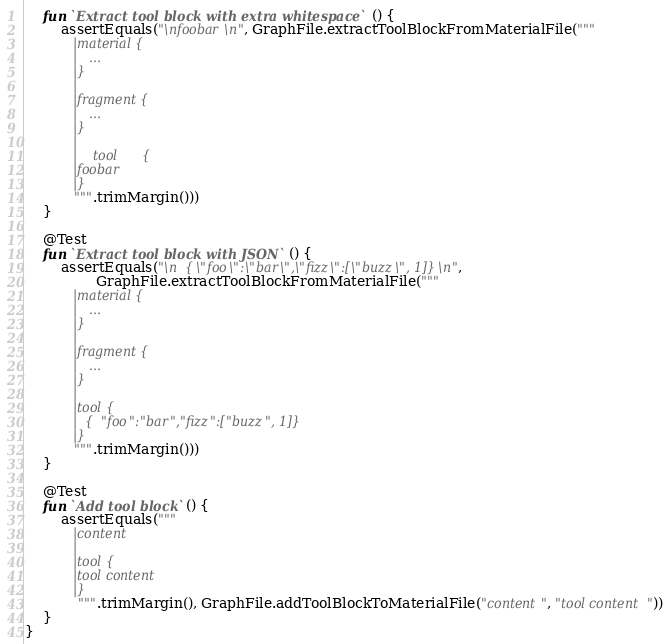<code> <loc_0><loc_0><loc_500><loc_500><_Kotlin_>    fun `Extract tool block with extra whitespace`() {
        assertEquals("\nfoobar\n", GraphFile.extractToolBlockFromMaterialFile("""
            |material {
            |   ...
            |}
            |
            |fragment {
            |   ...
            |}
            |
            |    tool      {
            |foobar
            |}
           """.trimMargin()))
    }

    @Test
    fun `Extract tool block with JSON`() {
        assertEquals("\n  {\"foo\":\"bar\",\"fizz\":[\"buzz\", 1]}\n",
                GraphFile.extractToolBlockFromMaterialFile("""
            |material {
            |   ...
            |}
            |
            |fragment {
            |   ...
            |}
            |
            |tool {
            |  {"foo":"bar","fizz":["buzz", 1]}
            |}
           """.trimMargin()))
    }

    @Test
    fun `Add tool block`() {
        assertEquals("""
            |content
            |
            |tool {
            |tool content
            |}
            """.trimMargin(), GraphFile.addToolBlockToMaterialFile("content", "tool content"))
    }
}</code> 